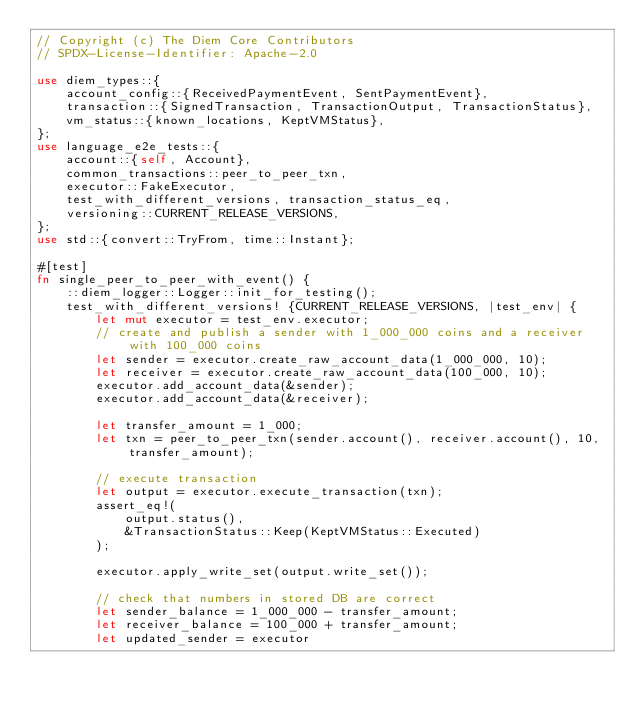Convert code to text. <code><loc_0><loc_0><loc_500><loc_500><_Rust_>// Copyright (c) The Diem Core Contributors
// SPDX-License-Identifier: Apache-2.0

use diem_types::{
    account_config::{ReceivedPaymentEvent, SentPaymentEvent},
    transaction::{SignedTransaction, TransactionOutput, TransactionStatus},
    vm_status::{known_locations, KeptVMStatus},
};
use language_e2e_tests::{
    account::{self, Account},
    common_transactions::peer_to_peer_txn,
    executor::FakeExecutor,
    test_with_different_versions, transaction_status_eq,
    versioning::CURRENT_RELEASE_VERSIONS,
};
use std::{convert::TryFrom, time::Instant};

#[test]
fn single_peer_to_peer_with_event() {
    ::diem_logger::Logger::init_for_testing();
    test_with_different_versions! {CURRENT_RELEASE_VERSIONS, |test_env| {
        let mut executor = test_env.executor;
        // create and publish a sender with 1_000_000 coins and a receiver with 100_000 coins
        let sender = executor.create_raw_account_data(1_000_000, 10);
        let receiver = executor.create_raw_account_data(100_000, 10);
        executor.add_account_data(&sender);
        executor.add_account_data(&receiver);

        let transfer_amount = 1_000;
        let txn = peer_to_peer_txn(sender.account(), receiver.account(), 10, transfer_amount);

        // execute transaction
        let output = executor.execute_transaction(txn);
        assert_eq!(
            output.status(),
            &TransactionStatus::Keep(KeptVMStatus::Executed)
        );

        executor.apply_write_set(output.write_set());

        // check that numbers in stored DB are correct
        let sender_balance = 1_000_000 - transfer_amount;
        let receiver_balance = 100_000 + transfer_amount;
        let updated_sender = executor</code> 